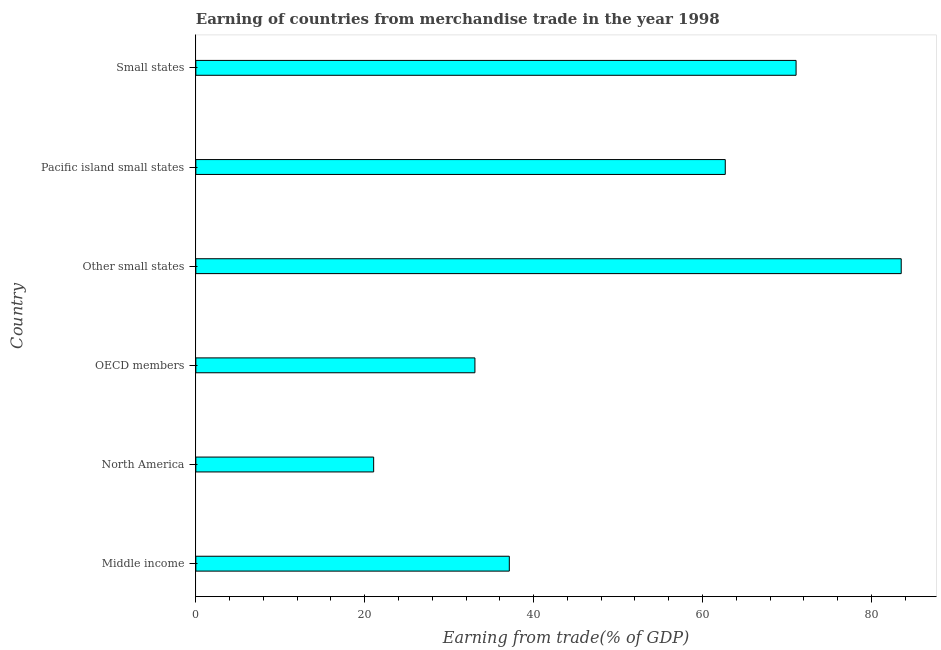What is the title of the graph?
Give a very brief answer. Earning of countries from merchandise trade in the year 1998. What is the label or title of the X-axis?
Provide a succinct answer. Earning from trade(% of GDP). What is the label or title of the Y-axis?
Your answer should be very brief. Country. What is the earning from merchandise trade in OECD members?
Your response must be concise. 33.05. Across all countries, what is the maximum earning from merchandise trade?
Give a very brief answer. 83.53. Across all countries, what is the minimum earning from merchandise trade?
Your answer should be compact. 21.06. In which country was the earning from merchandise trade maximum?
Ensure brevity in your answer.  Other small states. In which country was the earning from merchandise trade minimum?
Ensure brevity in your answer.  North America. What is the sum of the earning from merchandise trade?
Give a very brief answer. 308.53. What is the difference between the earning from merchandise trade in Other small states and Pacific island small states?
Offer a very short reply. 20.84. What is the average earning from merchandise trade per country?
Offer a very short reply. 51.42. What is the median earning from merchandise trade?
Give a very brief answer. 49.91. In how many countries, is the earning from merchandise trade greater than 60 %?
Ensure brevity in your answer.  3. What is the ratio of the earning from merchandise trade in OECD members to that in Pacific island small states?
Your answer should be compact. 0.53. Is the earning from merchandise trade in Middle income less than that in Pacific island small states?
Your answer should be compact. Yes. What is the difference between the highest and the second highest earning from merchandise trade?
Ensure brevity in your answer.  12.45. Is the sum of the earning from merchandise trade in Middle income and North America greater than the maximum earning from merchandise trade across all countries?
Make the answer very short. No. What is the difference between the highest and the lowest earning from merchandise trade?
Keep it short and to the point. 62.47. In how many countries, is the earning from merchandise trade greater than the average earning from merchandise trade taken over all countries?
Give a very brief answer. 3. What is the difference between two consecutive major ticks on the X-axis?
Make the answer very short. 20. Are the values on the major ticks of X-axis written in scientific E-notation?
Provide a short and direct response. No. What is the Earning from trade(% of GDP) in Middle income?
Ensure brevity in your answer.  37.12. What is the Earning from trade(% of GDP) in North America?
Provide a succinct answer. 21.06. What is the Earning from trade(% of GDP) in OECD members?
Offer a terse response. 33.05. What is the Earning from trade(% of GDP) of Other small states?
Your answer should be compact. 83.53. What is the Earning from trade(% of GDP) in Pacific island small states?
Offer a terse response. 62.69. What is the Earning from trade(% of GDP) of Small states?
Your answer should be compact. 71.08. What is the difference between the Earning from trade(% of GDP) in Middle income and North America?
Your answer should be compact. 16.06. What is the difference between the Earning from trade(% of GDP) in Middle income and OECD members?
Offer a terse response. 4.07. What is the difference between the Earning from trade(% of GDP) in Middle income and Other small states?
Your answer should be very brief. -46.41. What is the difference between the Earning from trade(% of GDP) in Middle income and Pacific island small states?
Provide a succinct answer. -25.57. What is the difference between the Earning from trade(% of GDP) in Middle income and Small states?
Ensure brevity in your answer.  -33.96. What is the difference between the Earning from trade(% of GDP) in North America and OECD members?
Your answer should be very brief. -11.99. What is the difference between the Earning from trade(% of GDP) in North America and Other small states?
Provide a short and direct response. -62.47. What is the difference between the Earning from trade(% of GDP) in North America and Pacific island small states?
Ensure brevity in your answer.  -41.64. What is the difference between the Earning from trade(% of GDP) in North America and Small states?
Offer a terse response. -50.02. What is the difference between the Earning from trade(% of GDP) in OECD members and Other small states?
Your answer should be very brief. -50.48. What is the difference between the Earning from trade(% of GDP) in OECD members and Pacific island small states?
Offer a terse response. -29.65. What is the difference between the Earning from trade(% of GDP) in OECD members and Small states?
Ensure brevity in your answer.  -38.03. What is the difference between the Earning from trade(% of GDP) in Other small states and Pacific island small states?
Your answer should be very brief. 20.84. What is the difference between the Earning from trade(% of GDP) in Other small states and Small states?
Offer a very short reply. 12.45. What is the difference between the Earning from trade(% of GDP) in Pacific island small states and Small states?
Your answer should be compact. -8.38. What is the ratio of the Earning from trade(% of GDP) in Middle income to that in North America?
Provide a succinct answer. 1.76. What is the ratio of the Earning from trade(% of GDP) in Middle income to that in OECD members?
Your answer should be very brief. 1.12. What is the ratio of the Earning from trade(% of GDP) in Middle income to that in Other small states?
Offer a terse response. 0.44. What is the ratio of the Earning from trade(% of GDP) in Middle income to that in Pacific island small states?
Offer a very short reply. 0.59. What is the ratio of the Earning from trade(% of GDP) in Middle income to that in Small states?
Keep it short and to the point. 0.52. What is the ratio of the Earning from trade(% of GDP) in North America to that in OECD members?
Your answer should be very brief. 0.64. What is the ratio of the Earning from trade(% of GDP) in North America to that in Other small states?
Offer a very short reply. 0.25. What is the ratio of the Earning from trade(% of GDP) in North America to that in Pacific island small states?
Provide a succinct answer. 0.34. What is the ratio of the Earning from trade(% of GDP) in North America to that in Small states?
Offer a terse response. 0.3. What is the ratio of the Earning from trade(% of GDP) in OECD members to that in Other small states?
Provide a succinct answer. 0.4. What is the ratio of the Earning from trade(% of GDP) in OECD members to that in Pacific island small states?
Your answer should be very brief. 0.53. What is the ratio of the Earning from trade(% of GDP) in OECD members to that in Small states?
Ensure brevity in your answer.  0.47. What is the ratio of the Earning from trade(% of GDP) in Other small states to that in Pacific island small states?
Keep it short and to the point. 1.33. What is the ratio of the Earning from trade(% of GDP) in Other small states to that in Small states?
Provide a short and direct response. 1.18. What is the ratio of the Earning from trade(% of GDP) in Pacific island small states to that in Small states?
Your answer should be very brief. 0.88. 